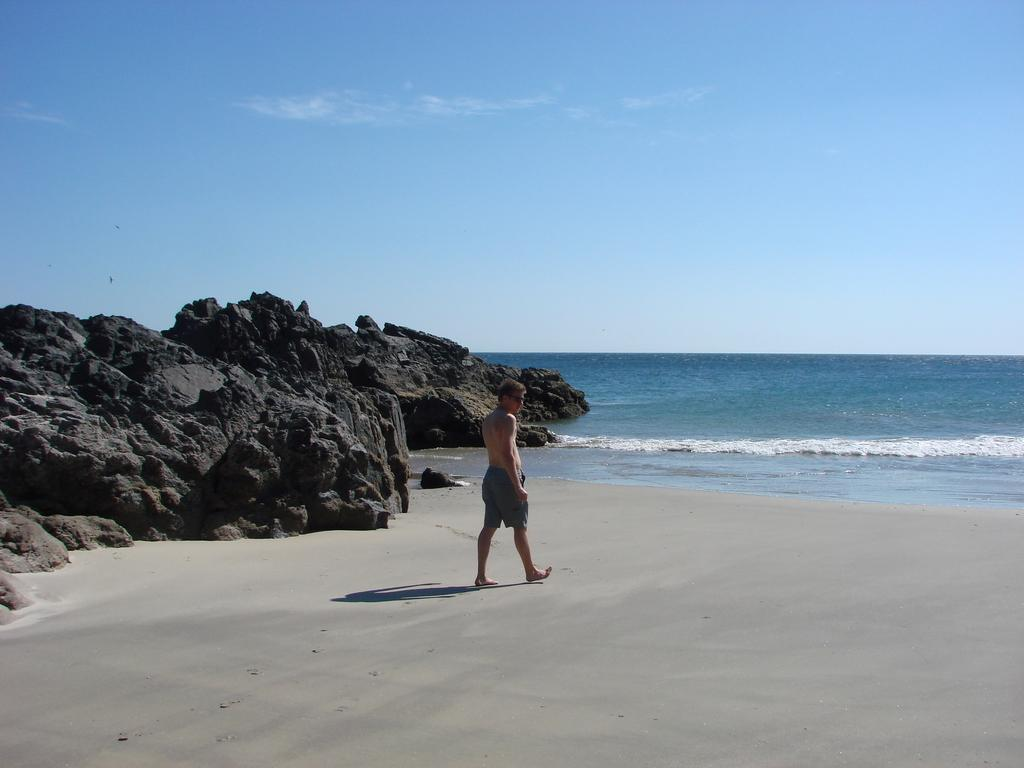What is the person in the image doing? The person is walking in the image. Where is the person walking? The person is walking on the sea shore. What can be seen beside the sea shore? There are rocks beside the sea shore. What is visible at the top of the image? The sky is visible at the top of the image. How many trees are coiled around the person in the image? There are no trees or coils present in the image; the person is walking on the sea shore with rocks beside it. 